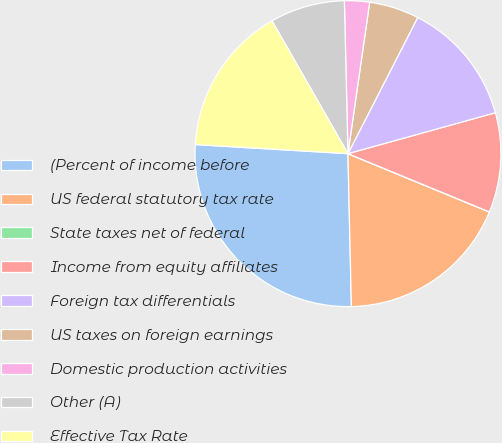Convert chart. <chart><loc_0><loc_0><loc_500><loc_500><pie_chart><fcel>(Percent of income before<fcel>US federal statutory tax rate<fcel>State taxes net of federal<fcel>Income from equity affiliates<fcel>Foreign tax differentials<fcel>US taxes on foreign earnings<fcel>Domestic production activities<fcel>Other (A)<fcel>Effective Tax Rate<nl><fcel>26.31%<fcel>18.42%<fcel>0.01%<fcel>10.53%<fcel>13.16%<fcel>5.27%<fcel>2.64%<fcel>7.9%<fcel>15.79%<nl></chart> 